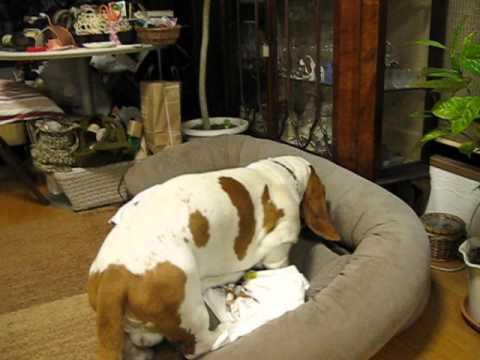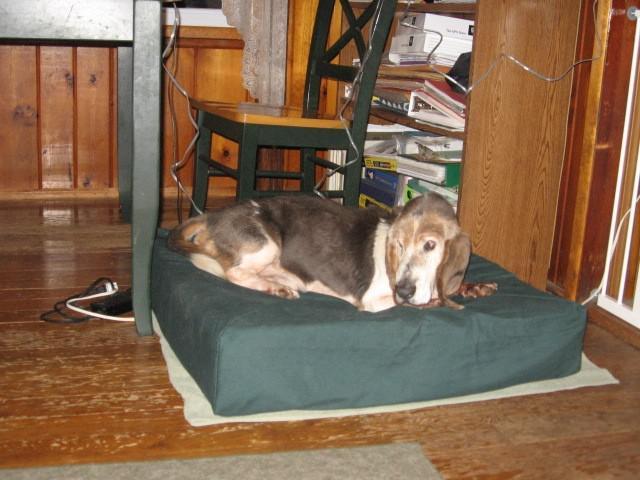The first image is the image on the left, the second image is the image on the right. Considering the images on both sides, is "One image shows two adult basset hounds sleeping in a round dog bed together" valid? Answer yes or no. No. The first image is the image on the left, the second image is the image on the right. Examine the images to the left and right. Is the description "Two basset hounds snuggle together in a round pet bed, in one image." accurate? Answer yes or no. No. 